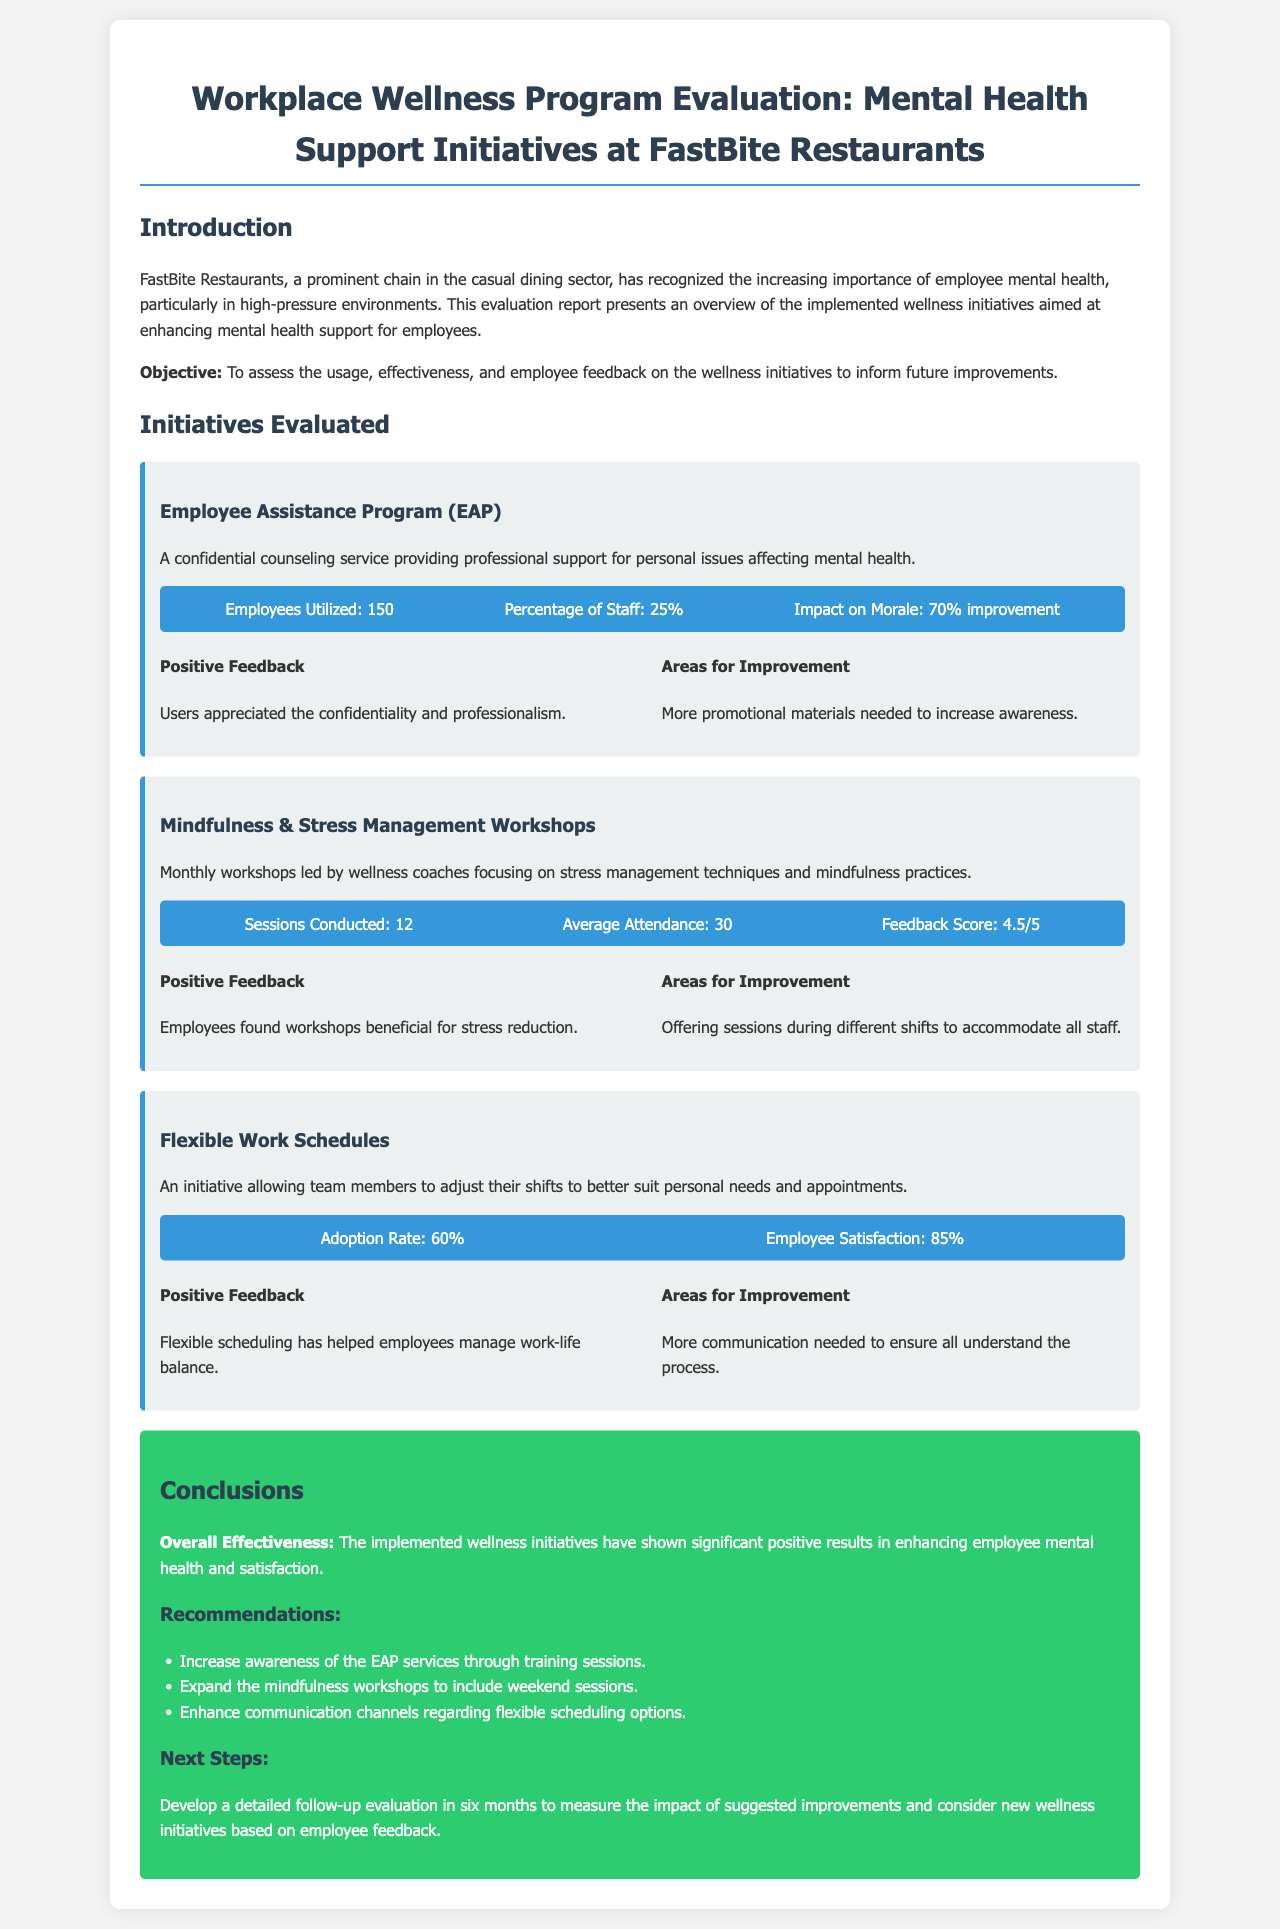What is the overall objective of the report? The objective is to assess the usage, effectiveness, and employee feedback on the wellness initiatives to inform future improvements.
Answer: To assess the usage, effectiveness, and employee feedback How many employees utilized the Employee Assistance Program? The document states that 150 employees utilized the program.
Answer: 150 What is the average attendance for the Mindfulness & Stress Management Workshops? The average attendance for the workshops is specified as 30.
Answer: 30 What percentage of staff utilized the Employee Assistance Program? The document indicates that 25% of staff utilized the program.
Answer: 25% What improvements are suggested for the Employee Assistance Program? The report suggests that more promotional materials are needed to increase awareness.
Answer: More promotional materials needed What was the feedback score for the Mindfulness & Stress Management Workshops? The feedback score is recorded as 4.5 out of 5.
Answer: 4.5/5 What is the employee satisfaction rate for Flexible Work Schedules? The document states that the employee satisfaction rate is 85%.
Answer: 85% What is one recommended next step mentioned in the report? A detailed follow-up evaluation in six months is recommended to measure the impact.
Answer: Develop a detailed follow-up evaluation How many sessions of Mindfulness Workshops were conducted? The number of sessions conducted is listed as 12.
Answer: 12 What main area for improvement is mentioned for Flexible Work Schedules? The report mentions that more communication is needed to ensure all understand the process.
Answer: More communication needed 